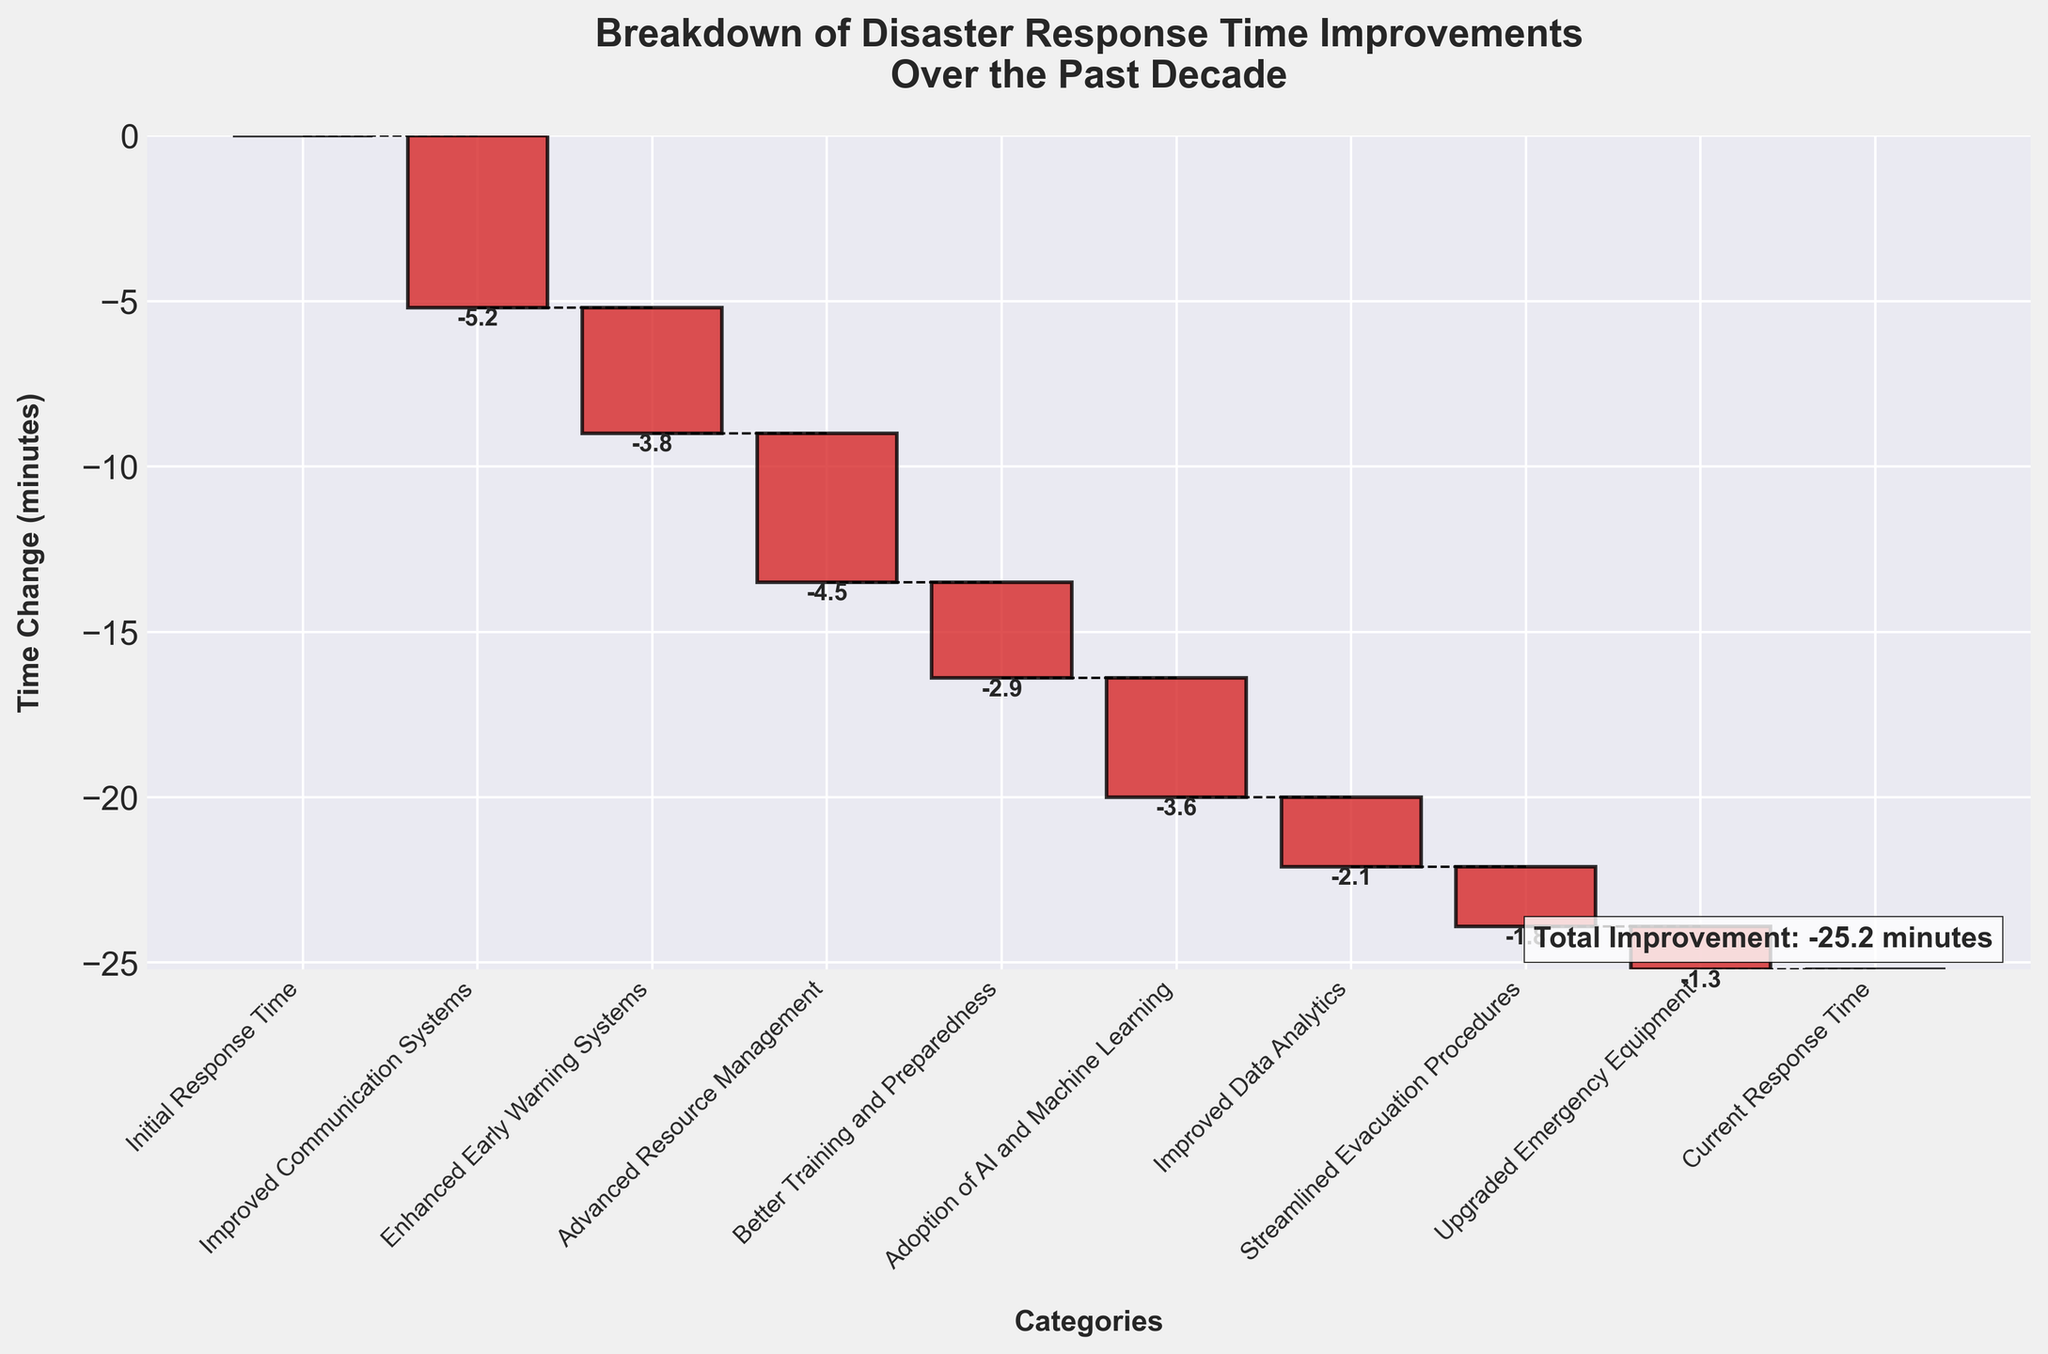What is the title of the plot? The title of the plot is usually provided at the top of the figure. In this case, the title is "Breakdown of Disaster Response Time Improvements Over the Past Decade".
Answer: Breakdown of Disaster Response Time Improvements Over the Past Decade What are the categories listed on the x-axis? The categories listed on the x-axis can be read directly from the figure. They include "Initial Response Time", "Improved Communication Systems", "Enhanced Early Warning Systems", "Advanced Resource Management", "Better Training and Preparedness", "Adoption of AI and Machine Learning", "Improved Data Analytics", "Streamlined Evacuation Procedures", "Upgraded Emergency Equipment", and "Current Response Time".
Answer: Initial Response Time, Improved Communication Systems, Enhanced Early Warning Systems, Advanced Resource Management, Better Training and Preparedness, Adoption of AI and Machine Learning, Improved Data Analytics, Streamlined Evacuation Procedures, Upgraded Emergency Equipment, Current Response Time Which category has the largest improvement in response time? The category with the largest negative value in the figure represents the largest improvement in response time. "Improved Communication Systems" shows a reduction of -5.2 minutes.
Answer: Improved Communication Systems What is the total improvement in disaster response time over the past decade? The total improvement is the sum of all individual improvements shown in the figure, excluding the initial and current response times. These values are -5.2, -3.8, -4.5, -2.9, -3.6, -2.1, -1.8, and -1.3. Adding these gives: -5.2 + -3.8 + -4.5 + -2.9 + -3.6 + -2.1 + -1.8 + -1.3 = -25.2 minutes, which matches the total improvement text in the figure.
Answer: -25.2 minutes How do the improvements from "Advanced Resource Management" and "Adoption of AI and Machine Learning" compare? By comparing the bars for both categories in the figure, "Advanced Resource Management" shows a reduction of -4.5 minutes, and "Adoption of AI and Machine Learning" shows a reduction of -3.6 minutes. Therefore, the improvement in Advanced Resource Management is greater.
Answer: "Advanced Resource Management" has a greater improvement Which improvement category is closest to reducing the response time by 2 minutes? The figure shows "Improved Data Analytics" as a category that reduces the response time by approximately -2.1 minutes, which is closest to reducing the response time by 2 minutes.
Answer: Improved Data Analytics What is the cumulative response time improvement after "Better Training and Preparedness"? The cumulative improvement is calculated by summing the values from the start up to "Better Training and Preparedness": -5.2 (Improved Communication Systems) + -3.8 (Enhanced Early Warning Systems) + -4.5 (Advanced Resource Management) + -2.9 (Better Training and Preparedness) = -16.4 minutes.
Answer: -16.4 minutes 